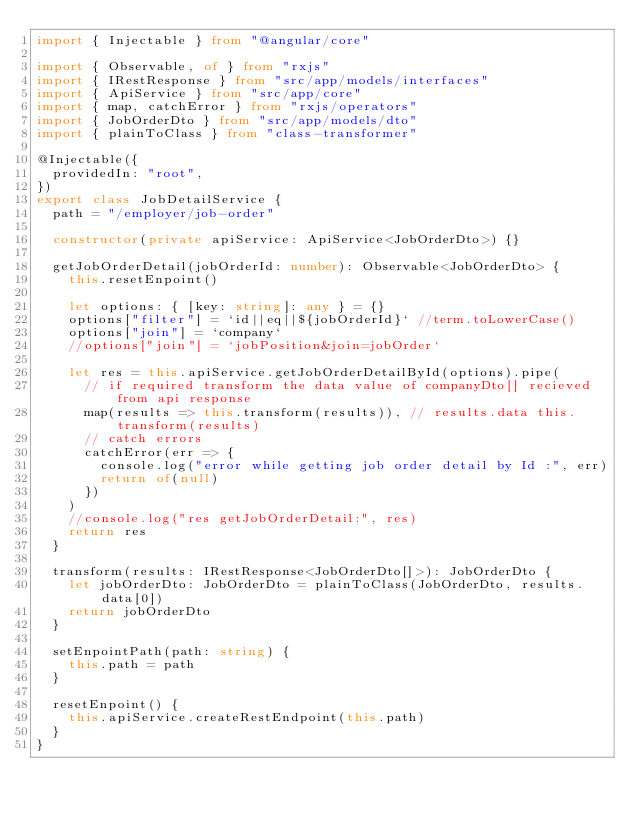Convert code to text. <code><loc_0><loc_0><loc_500><loc_500><_TypeScript_>import { Injectable } from "@angular/core"

import { Observable, of } from "rxjs"
import { IRestResponse } from "src/app/models/interfaces"
import { ApiService } from "src/app/core"
import { map, catchError } from "rxjs/operators"
import { JobOrderDto } from "src/app/models/dto"
import { plainToClass } from "class-transformer"

@Injectable({
  providedIn: "root",
})
export class JobDetailService {
  path = "/employer/job-order"

  constructor(private apiService: ApiService<JobOrderDto>) {}

  getJobOrderDetail(jobOrderId: number): Observable<JobOrderDto> {
    this.resetEnpoint()

    let options: { [key: string]: any } = {}
    options["filter"] = `id||eq||${jobOrderId}` //term.toLowerCase()
    options["join"] = `company`
    //options["join"] = `jobPosition&join=jobOrder`

    let res = this.apiService.getJobOrderDetailById(options).pipe(
      // if required transform the data value of companyDto[] recieved from api response
      map(results => this.transform(results)), // results.data this.transform(results)
      // catch errors
      catchError(err => {
        console.log("error while getting job order detail by Id :", err)
        return of(null)
      })
    )
    //console.log("res getJobOrderDetail:", res)
    return res
  }

  transform(results: IRestResponse<JobOrderDto[]>): JobOrderDto {
    let jobOrderDto: JobOrderDto = plainToClass(JobOrderDto, results.data[0])
    return jobOrderDto
  }

  setEnpointPath(path: string) {
    this.path = path
  }

  resetEnpoint() {
    this.apiService.createRestEndpoint(this.path)
  }
}
</code> 